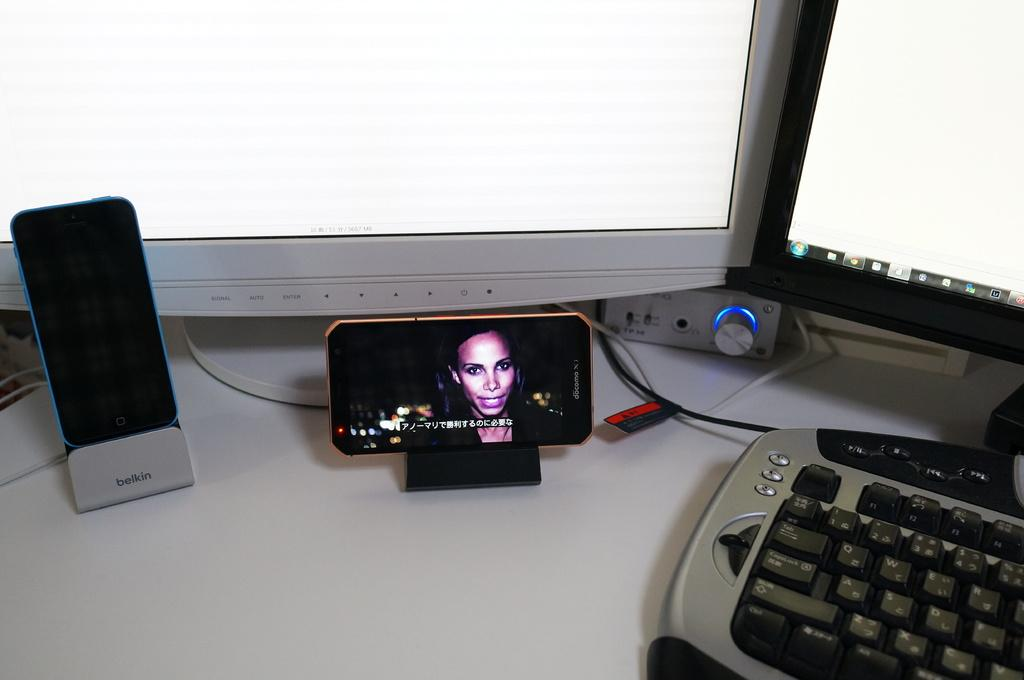What type of devices can be seen in the image? There are mobiles on mobile holders, monitors, and keyboards in the image. What might be used to connect the devices in the image? Cables can be seen in the image, which might be used to connect the devices. What is present on the table in the image? There is an object on the table in the image. What type of jar can be seen on the curtain in the image? There is no jar or curtain present in the image. 